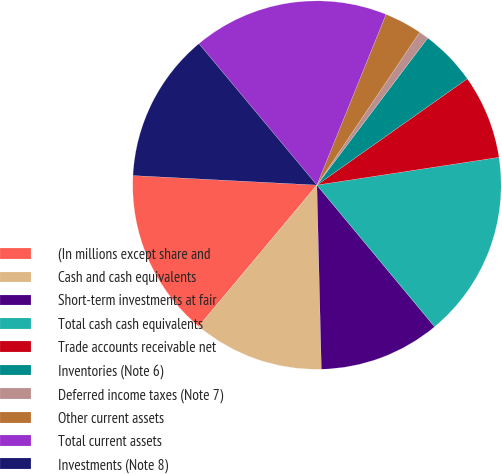Convert chart. <chart><loc_0><loc_0><loc_500><loc_500><pie_chart><fcel>(In millions except share and<fcel>Cash and cash equivalents<fcel>Short-term investments at fair<fcel>Total cash cash equivalents<fcel>Trade accounts receivable net<fcel>Inventories (Note 6)<fcel>Deferred income taxes (Note 7)<fcel>Other current assets<fcel>Total current assets<fcel>Investments (Note 8)<nl><fcel>14.74%<fcel>11.47%<fcel>10.65%<fcel>16.37%<fcel>7.39%<fcel>4.93%<fcel>0.85%<fcel>3.3%<fcel>17.19%<fcel>13.11%<nl></chart> 